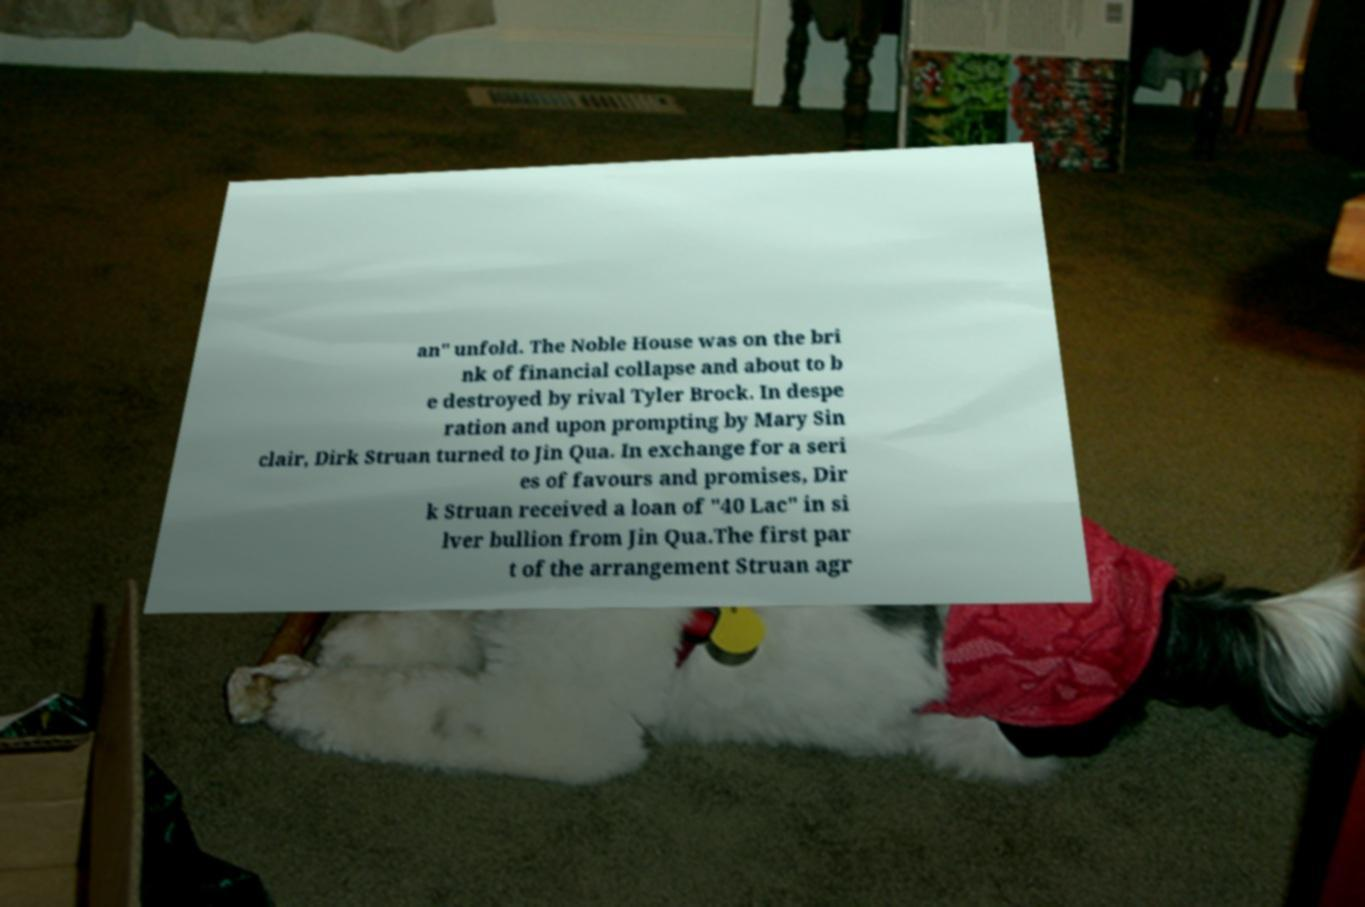For documentation purposes, I need the text within this image transcribed. Could you provide that? an" unfold. The Noble House was on the bri nk of financial collapse and about to b e destroyed by rival Tyler Brock. In despe ration and upon prompting by Mary Sin clair, Dirk Struan turned to Jin Qua. In exchange for a seri es of favours and promises, Dir k Struan received a loan of "40 Lac" in si lver bullion from Jin Qua.The first par t of the arrangement Struan agr 